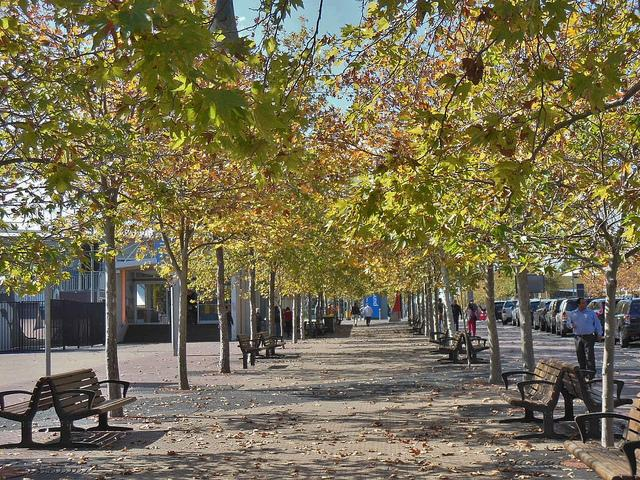What season of the year is it? Please explain your reasoning. autumn. The ground is covered in fallen leaves. 